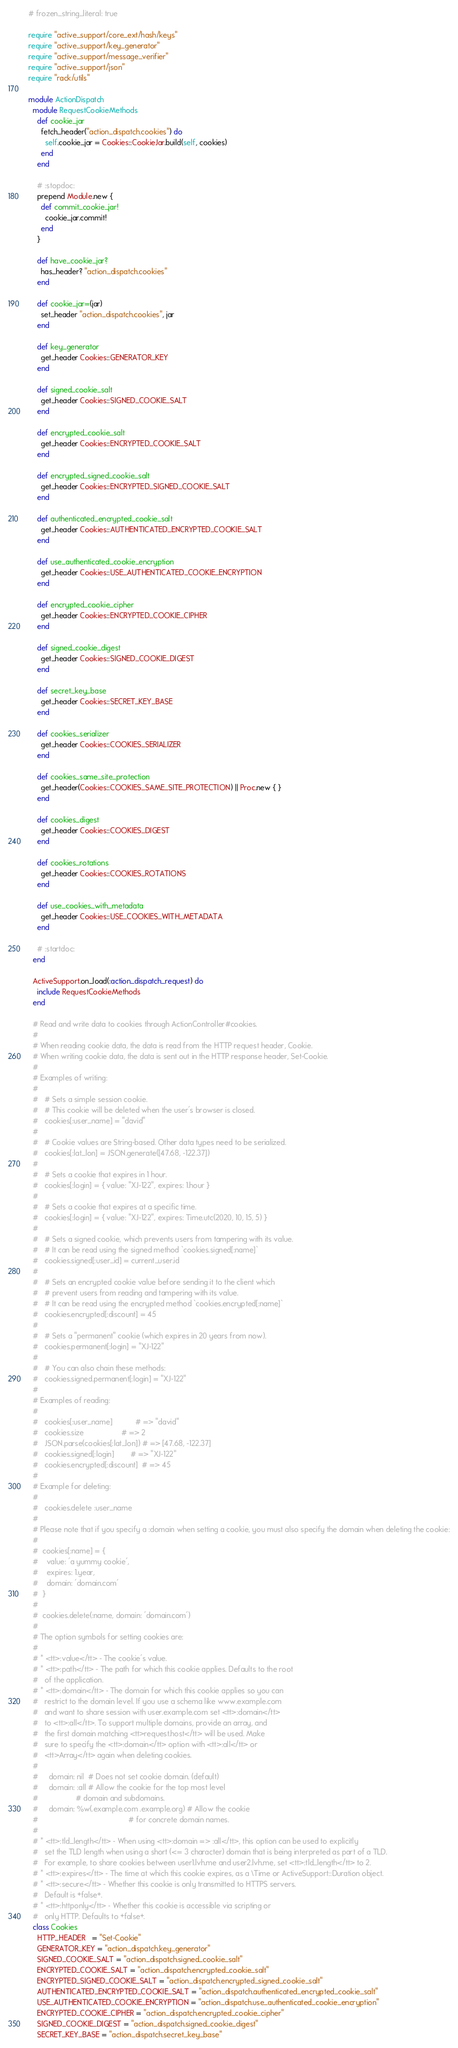Convert code to text. <code><loc_0><loc_0><loc_500><loc_500><_Ruby_># frozen_string_literal: true

require "active_support/core_ext/hash/keys"
require "active_support/key_generator"
require "active_support/message_verifier"
require "active_support/json"
require "rack/utils"

module ActionDispatch
  module RequestCookieMethods
    def cookie_jar
      fetch_header("action_dispatch.cookies") do
        self.cookie_jar = Cookies::CookieJar.build(self, cookies)
      end
    end

    # :stopdoc:
    prepend Module.new {
      def commit_cookie_jar!
        cookie_jar.commit!
      end
    }

    def have_cookie_jar?
      has_header? "action_dispatch.cookies"
    end

    def cookie_jar=(jar)
      set_header "action_dispatch.cookies", jar
    end

    def key_generator
      get_header Cookies::GENERATOR_KEY
    end

    def signed_cookie_salt
      get_header Cookies::SIGNED_COOKIE_SALT
    end

    def encrypted_cookie_salt
      get_header Cookies::ENCRYPTED_COOKIE_SALT
    end

    def encrypted_signed_cookie_salt
      get_header Cookies::ENCRYPTED_SIGNED_COOKIE_SALT
    end

    def authenticated_encrypted_cookie_salt
      get_header Cookies::AUTHENTICATED_ENCRYPTED_COOKIE_SALT
    end

    def use_authenticated_cookie_encryption
      get_header Cookies::USE_AUTHENTICATED_COOKIE_ENCRYPTION
    end

    def encrypted_cookie_cipher
      get_header Cookies::ENCRYPTED_COOKIE_CIPHER
    end

    def signed_cookie_digest
      get_header Cookies::SIGNED_COOKIE_DIGEST
    end

    def secret_key_base
      get_header Cookies::SECRET_KEY_BASE
    end

    def cookies_serializer
      get_header Cookies::COOKIES_SERIALIZER
    end

    def cookies_same_site_protection
      get_header(Cookies::COOKIES_SAME_SITE_PROTECTION) || Proc.new { }
    end

    def cookies_digest
      get_header Cookies::COOKIES_DIGEST
    end

    def cookies_rotations
      get_header Cookies::COOKIES_ROTATIONS
    end

    def use_cookies_with_metadata
      get_header Cookies::USE_COOKIES_WITH_METADATA
    end

    # :startdoc:
  end

  ActiveSupport.on_load(:action_dispatch_request) do
    include RequestCookieMethods
  end

  # Read and write data to cookies through ActionController#cookies.
  #
  # When reading cookie data, the data is read from the HTTP request header, Cookie.
  # When writing cookie data, the data is sent out in the HTTP response header, Set-Cookie.
  #
  # Examples of writing:
  #
  #   # Sets a simple session cookie.
  #   # This cookie will be deleted when the user's browser is closed.
  #   cookies[:user_name] = "david"
  #
  #   # Cookie values are String-based. Other data types need to be serialized.
  #   cookies[:lat_lon] = JSON.generate([47.68, -122.37])
  #
  #   # Sets a cookie that expires in 1 hour.
  #   cookies[:login] = { value: "XJ-122", expires: 1.hour }
  #
  #   # Sets a cookie that expires at a specific time.
  #   cookies[:login] = { value: "XJ-122", expires: Time.utc(2020, 10, 15, 5) }
  #
  #   # Sets a signed cookie, which prevents users from tampering with its value.
  #   # It can be read using the signed method `cookies.signed[:name]`
  #   cookies.signed[:user_id] = current_user.id
  #
  #   # Sets an encrypted cookie value before sending it to the client which
  #   # prevent users from reading and tampering with its value.
  #   # It can be read using the encrypted method `cookies.encrypted[:name]`
  #   cookies.encrypted[:discount] = 45
  #
  #   # Sets a "permanent" cookie (which expires in 20 years from now).
  #   cookies.permanent[:login] = "XJ-122"
  #
  #   # You can also chain these methods:
  #   cookies.signed.permanent[:login] = "XJ-122"
  #
  # Examples of reading:
  #
  #   cookies[:user_name]           # => "david"
  #   cookies.size                  # => 2
  #   JSON.parse(cookies[:lat_lon]) # => [47.68, -122.37]
  #   cookies.signed[:login]        # => "XJ-122"
  #   cookies.encrypted[:discount]  # => 45
  #
  # Example for deleting:
  #
  #   cookies.delete :user_name
  #
  # Please note that if you specify a :domain when setting a cookie, you must also specify the domain when deleting the cookie:
  #
  #  cookies[:name] = {
  #    value: 'a yummy cookie',
  #    expires: 1.year,
  #    domain: 'domain.com'
  #  }
  #
  #  cookies.delete(:name, domain: 'domain.com')
  #
  # The option symbols for setting cookies are:
  #
  # * <tt>:value</tt> - The cookie's value.
  # * <tt>:path</tt> - The path for which this cookie applies. Defaults to the root
  #   of the application.
  # * <tt>:domain</tt> - The domain for which this cookie applies so you can
  #   restrict to the domain level. If you use a schema like www.example.com
  #   and want to share session with user.example.com set <tt>:domain</tt>
  #   to <tt>:all</tt>. To support multiple domains, provide an array, and
  #   the first domain matching <tt>request.host</tt> will be used. Make
  #   sure to specify the <tt>:domain</tt> option with <tt>:all</tt> or
  #   <tt>Array</tt> again when deleting cookies.
  #
  #     domain: nil  # Does not set cookie domain. (default)
  #     domain: :all # Allow the cookie for the top most level
  #                  # domain and subdomains.
  #     domain: %w(.example.com .example.org) # Allow the cookie
  #                                           # for concrete domain names.
  #
  # * <tt>:tld_length</tt> - When using <tt>:domain => :all</tt>, this option can be used to explicitly
  #   set the TLD length when using a short (<= 3 character) domain that is being interpreted as part of a TLD.
  #   For example, to share cookies between user1.lvh.me and user2.lvh.me, set <tt>:tld_length</tt> to 2.
  # * <tt>:expires</tt> - The time at which this cookie expires, as a \Time or ActiveSupport::Duration object.
  # * <tt>:secure</tt> - Whether this cookie is only transmitted to HTTPS servers.
  #   Default is +false+.
  # * <tt>:httponly</tt> - Whether this cookie is accessible via scripting or
  #   only HTTP. Defaults to +false+.
  class Cookies
    HTTP_HEADER   = "Set-Cookie"
    GENERATOR_KEY = "action_dispatch.key_generator"
    SIGNED_COOKIE_SALT = "action_dispatch.signed_cookie_salt"
    ENCRYPTED_COOKIE_SALT = "action_dispatch.encrypted_cookie_salt"
    ENCRYPTED_SIGNED_COOKIE_SALT = "action_dispatch.encrypted_signed_cookie_salt"
    AUTHENTICATED_ENCRYPTED_COOKIE_SALT = "action_dispatch.authenticated_encrypted_cookie_salt"
    USE_AUTHENTICATED_COOKIE_ENCRYPTION = "action_dispatch.use_authenticated_cookie_encryption"
    ENCRYPTED_COOKIE_CIPHER = "action_dispatch.encrypted_cookie_cipher"
    SIGNED_COOKIE_DIGEST = "action_dispatch.signed_cookie_digest"
    SECRET_KEY_BASE = "action_dispatch.secret_key_base"</code> 